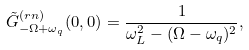Convert formula to latex. <formula><loc_0><loc_0><loc_500><loc_500>\tilde { G } _ { - \Omega + \omega _ { q } } ^ { ( r n ) } ( 0 , 0 ) = \frac { 1 } { \omega _ { L } ^ { 2 } - ( \Omega - \omega _ { q } ) ^ { 2 } } ,</formula> 